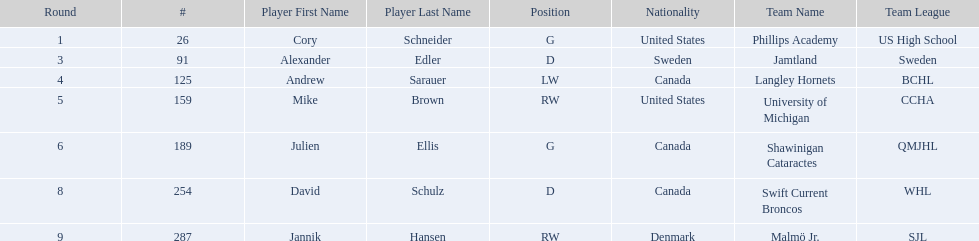Who are all the players? Cory Schneider (G), Alexander Edler (D), Andrew Sarauer (LW), Mike Brown (RW), Julien Ellis (G), David Schulz (D), Jannik Hansen (RW). What is the nationality of each player? United States, Sweden, Canada, United States, Canada, Canada, Denmark. Where did they attend school? Phillips Academy (US High School), Jamtland (Sweden), Langley Hornets (BCHL), University of Michigan (CCHA), Shawinigan Cataractes (QMJHL), Swift Current Broncos (WHL), Malmö Jr. (SJL). Which player attended langley hornets? Andrew Sarauer (LW). 